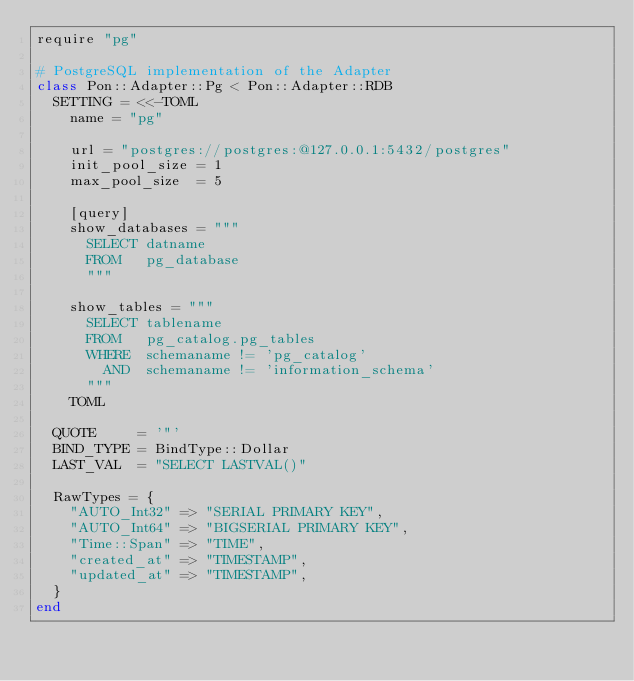<code> <loc_0><loc_0><loc_500><loc_500><_Crystal_>require "pg"

# PostgreSQL implementation of the Adapter
class Pon::Adapter::Pg < Pon::Adapter::RDB
  SETTING = <<-TOML
    name = "pg"

    url = "postgres://postgres:@127.0.0.1:5432/postgres"
    init_pool_size = 1
    max_pool_size  = 5

    [query]
    show_databases = """
      SELECT datname
      FROM   pg_database
      """

    show_tables = """
      SELECT tablename
      FROM   pg_catalog.pg_tables
      WHERE  schemaname != 'pg_catalog'
        AND  schemaname != 'information_schema'
      """
    TOML

  QUOTE     = '"'
  BIND_TYPE = BindType::Dollar
  LAST_VAL  = "SELECT LASTVAL()"

  RawTypes = {
    "AUTO_Int32" => "SERIAL PRIMARY KEY",
    "AUTO_Int64" => "BIGSERIAL PRIMARY KEY",
    "Time::Span" => "TIME",
    "created_at" => "TIMESTAMP",
    "updated_at" => "TIMESTAMP",
  }
end
</code> 